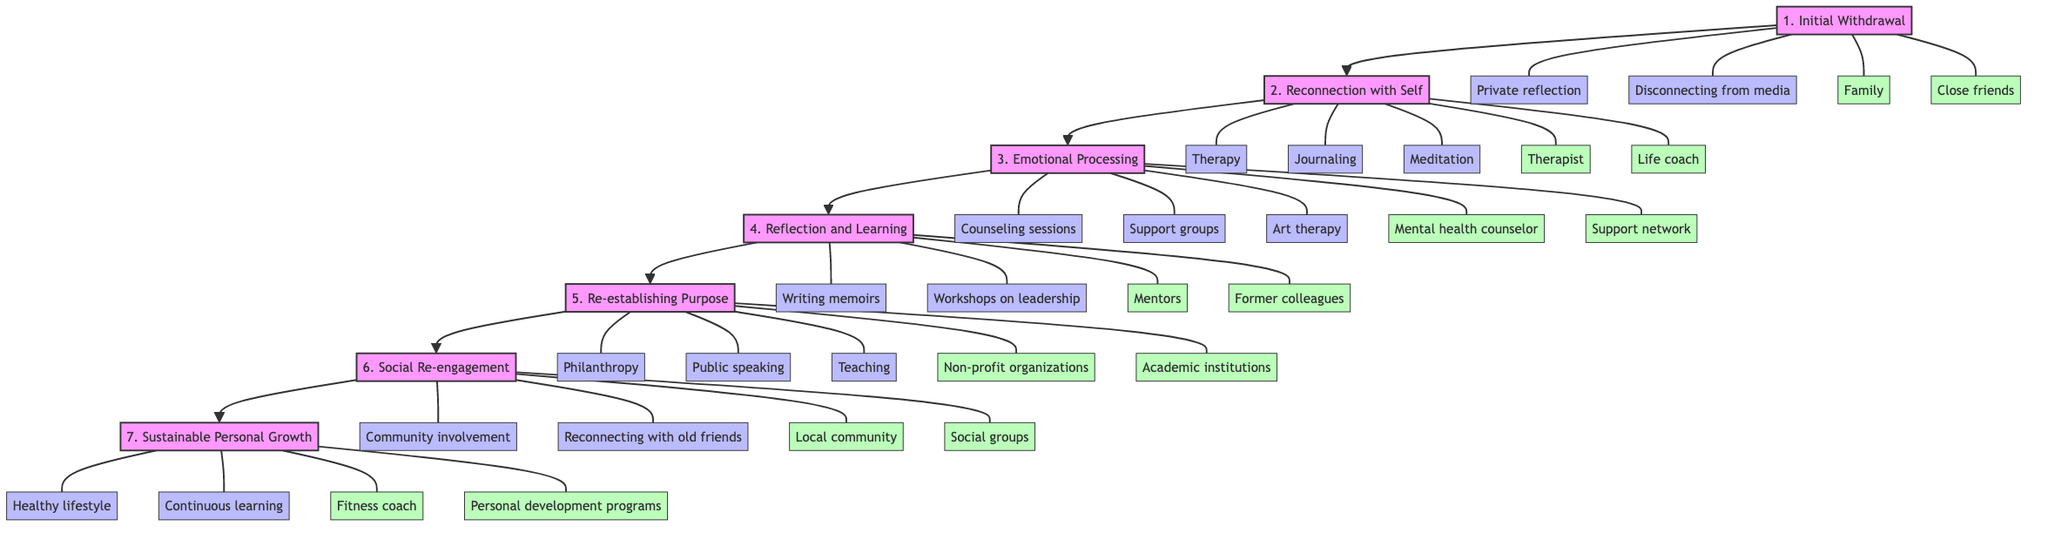What is the first stage of emotional recovery post-leadership? The diagram indicates that the first stage is labeled "1. Initial Withdrawal."
Answer: 1. Initial Withdrawal How many activities are associated with the "Reconnection with Self" stage? In the diagram, there are three activities linked to the "Reconnection with Self" stage: Therapy, Journaling, and Meditation.
Answer: 3 What type of support is mentioned for the "Emotional Processing" stage? The diagram lists two types of support for the "Emotional Processing" stage: Mental health counselor and Support network.
Answer: Mental health counselor, Support network Which stage follows "Reflection and Learning"? By tracing the flow of the diagram, it is clear that the stage that follows "Reflection and Learning" is "Re-establishing Purpose."
Answer: Re-establishing Purpose What activities are involved in the "Social Re-engagement" stage? According to the diagram, the activities in the "Social Re-engagement" stage are Community involvement and Reconnecting with old friends.
Answer: Community involvement, Reconnecting with old friends How many total stages are depicted in the diagram? Counting the nodes in the diagram, there are seven stages displayed in total.
Answer: 7 What is the last stage in the emotional recovery process? The final stage shown in the diagram is "Sustainable Personal Growth."
Answer: Sustainable Personal Growth Which support is provided during the "Re-establishing Purpose" stage? The diagram specifies two types of support for this stage: Non-profit organizations and Academic institutions.
Answer: Non-profit organizations, Academic institutions What is a key activity listed for the "Initial Withdrawal" stage? The diagram identifies two key activities for this stage: Private reflection and Disconnecting from media, but since it only asks for one, you can choose one of them.
Answer: Private reflection 